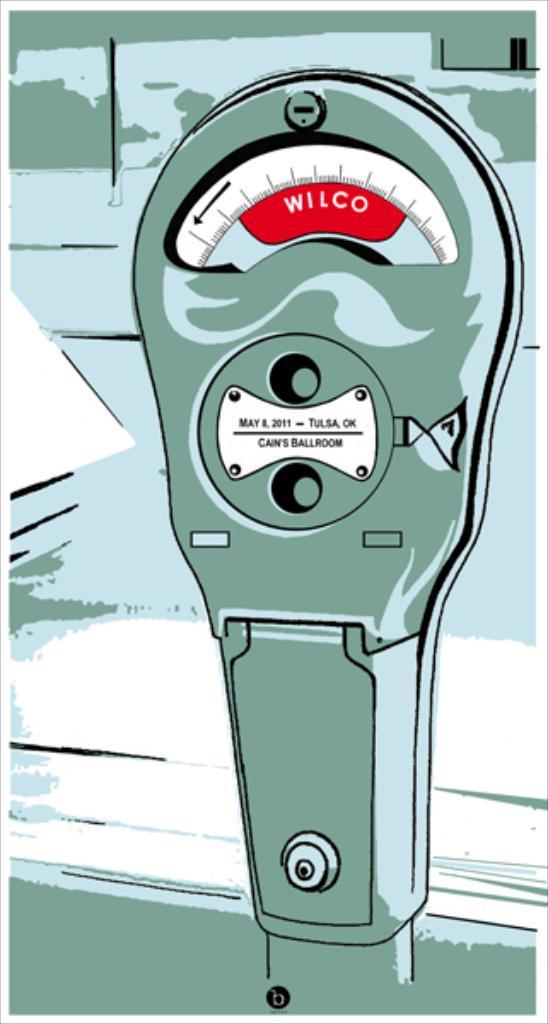What name is on the red tab?
Give a very brief answer. Wilco. 